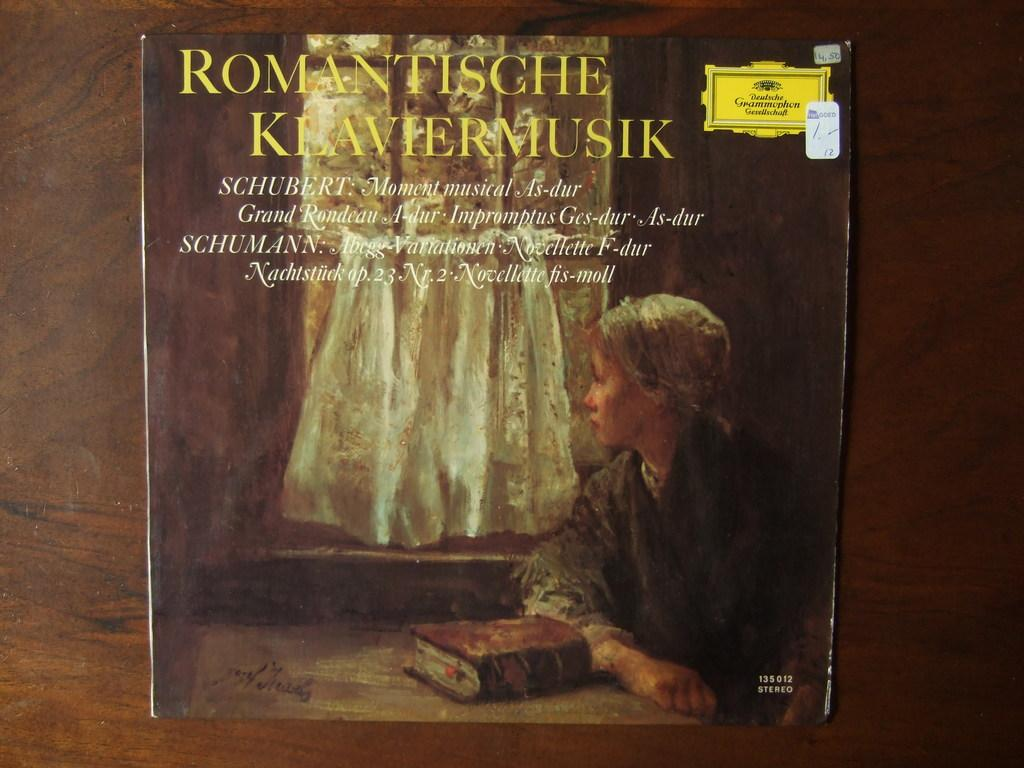<image>
Share a concise interpretation of the image provided. A woman looks out the window on the cover of this Romantische Klaviermusik album. 